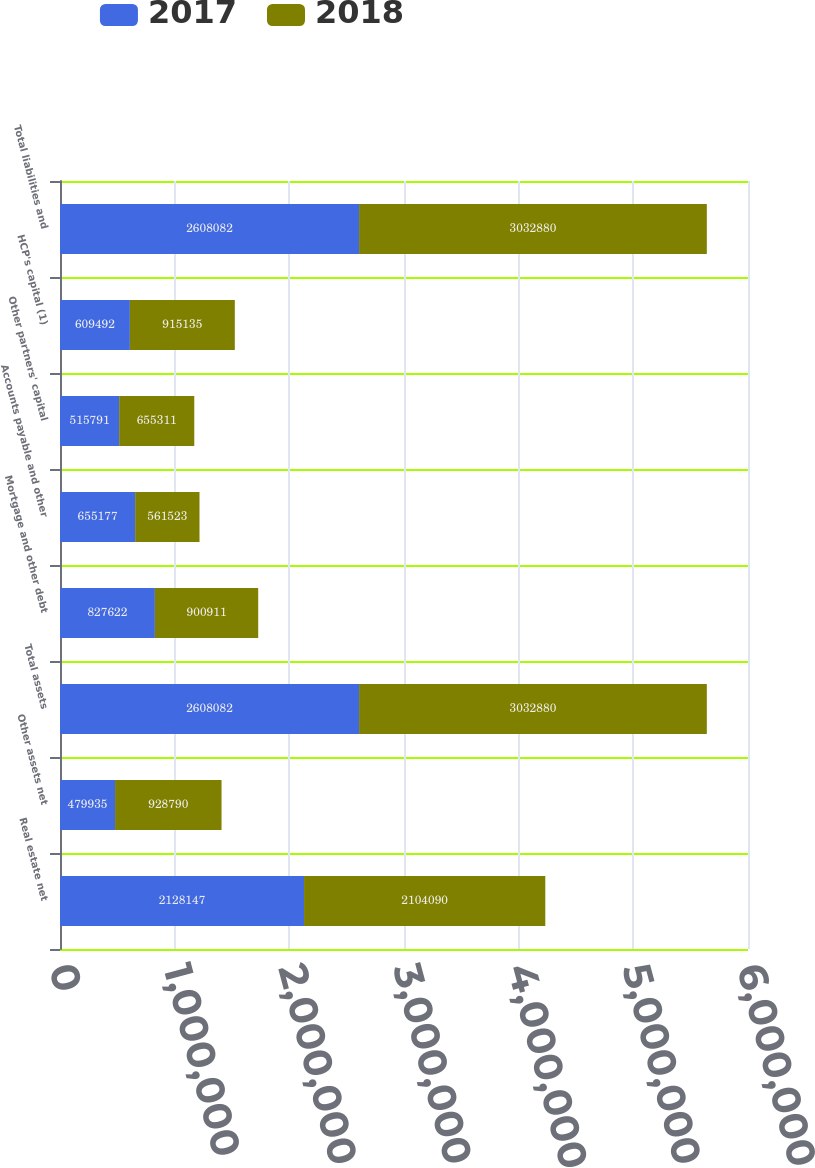Convert chart. <chart><loc_0><loc_0><loc_500><loc_500><stacked_bar_chart><ecel><fcel>Real estate net<fcel>Other assets net<fcel>Total assets<fcel>Mortgage and other debt<fcel>Accounts payable and other<fcel>Other partners' capital<fcel>HCP's capital (1)<fcel>Total liabilities and<nl><fcel>2017<fcel>2.12815e+06<fcel>479935<fcel>2.60808e+06<fcel>827622<fcel>655177<fcel>515791<fcel>609492<fcel>2.60808e+06<nl><fcel>2018<fcel>2.10409e+06<fcel>928790<fcel>3.03288e+06<fcel>900911<fcel>561523<fcel>655311<fcel>915135<fcel>3.03288e+06<nl></chart> 